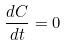<formula> <loc_0><loc_0><loc_500><loc_500>\frac { d C } { d t } = 0</formula> 